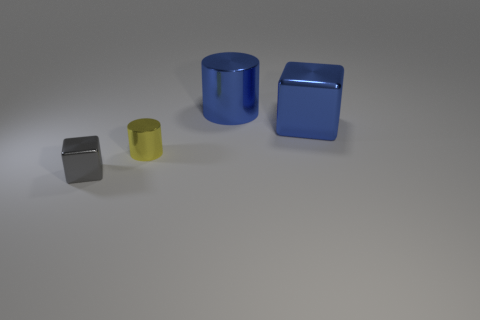Add 4 large blue cubes. How many objects exist? 8 Subtract all blue cubes. How many cubes are left? 1 Subtract 1 cylinders. How many cylinders are left? 1 Subtract all purple cylinders. Subtract all red balls. How many cylinders are left? 2 Add 1 small objects. How many small objects exist? 3 Subtract 0 purple blocks. How many objects are left? 4 Subtract all yellow cubes. How many red cylinders are left? 0 Subtract all yellow shiny things. Subtract all metal blocks. How many objects are left? 1 Add 4 yellow things. How many yellow things are left? 5 